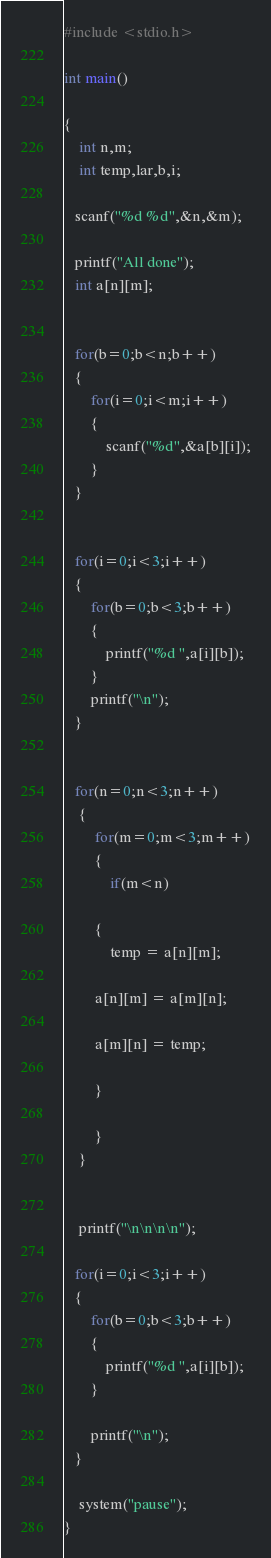<code> <loc_0><loc_0><loc_500><loc_500><_C_>#include <stdio.h>

int main()

{
    int n,m;
    int temp,lar,b,i;

   scanf("%d %d",&n,&m);

   printf("All done");
   int a[n][m];


   for(b=0;b<n;b++)
   {
       for(i=0;i<m;i++)
       {
           scanf("%d",&a[b][i]);
       }
   }


   for(i=0;i<3;i++)
   {
       for(b=0;b<3;b++)
       {
           printf("%d ",a[i][b]);
       }
       printf("\n");
   }


   for(n=0;n<3;n++)
    {
        for(m=0;m<3;m++)
        {
            if(m<n)

        {
            temp = a[n][m];

        a[n][m] = a[m][n];

        a[m][n] = temp;

        }

        }
    }


    printf("\n\n\n\n");

   for(i=0;i<3;i++)
   {
       for(b=0;b<3;b++)
       {
           printf("%d ",a[i][b]);
       }

       printf("\n");
   }

    system("pause");
}
</code> 